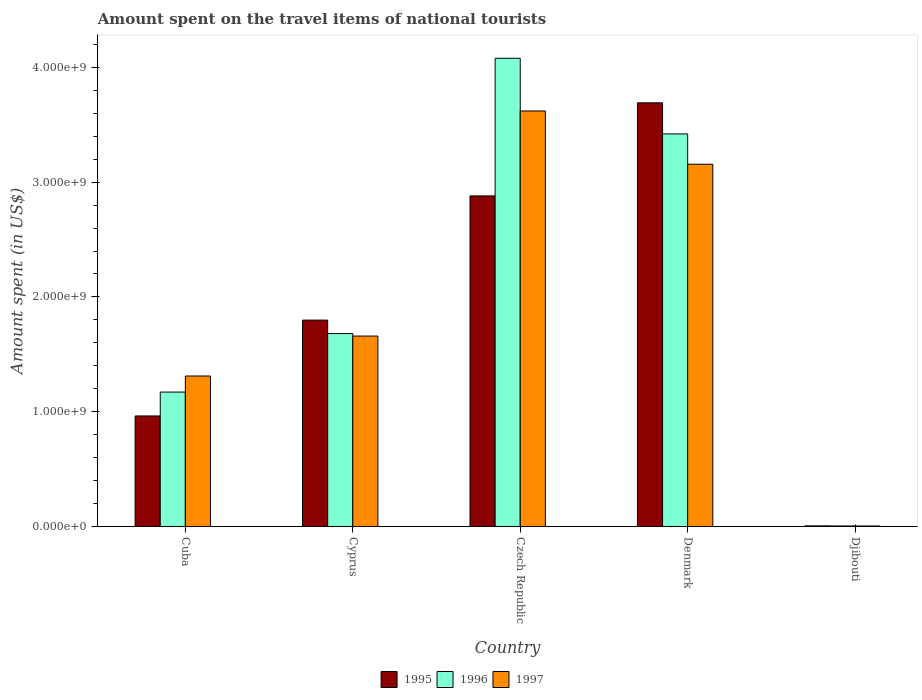How many groups of bars are there?
Offer a very short reply. 5. Are the number of bars per tick equal to the number of legend labels?
Your answer should be very brief. Yes. Are the number of bars on each tick of the X-axis equal?
Your answer should be very brief. Yes. How many bars are there on the 3rd tick from the right?
Your answer should be very brief. 3. What is the label of the 2nd group of bars from the left?
Provide a short and direct response. Cyprus. What is the amount spent on the travel items of national tourists in 1995 in Cuba?
Ensure brevity in your answer.  9.63e+08. Across all countries, what is the maximum amount spent on the travel items of national tourists in 1996?
Keep it short and to the point. 4.08e+09. Across all countries, what is the minimum amount spent on the travel items of national tourists in 1997?
Offer a terse response. 4.20e+06. In which country was the amount spent on the travel items of national tourists in 1996 maximum?
Provide a short and direct response. Czech Republic. In which country was the amount spent on the travel items of national tourists in 1996 minimum?
Provide a short and direct response. Djibouti. What is the total amount spent on the travel items of national tourists in 1996 in the graph?
Ensure brevity in your answer.  1.04e+1. What is the difference between the amount spent on the travel items of national tourists in 1997 in Cuba and that in Czech Republic?
Keep it short and to the point. -2.31e+09. What is the difference between the amount spent on the travel items of national tourists in 1996 in Czech Republic and the amount spent on the travel items of national tourists in 1997 in Djibouti?
Give a very brief answer. 4.07e+09. What is the average amount spent on the travel items of national tourists in 1997 per country?
Give a very brief answer. 1.95e+09. What is the difference between the amount spent on the travel items of national tourists of/in 1996 and amount spent on the travel items of national tourists of/in 1997 in Djibouti?
Keep it short and to the point. 4.00e+05. What is the ratio of the amount spent on the travel items of national tourists in 1996 in Cuba to that in Djibouti?
Ensure brevity in your answer.  254.57. What is the difference between the highest and the second highest amount spent on the travel items of national tourists in 1996?
Your answer should be compact. 6.59e+08. What is the difference between the highest and the lowest amount spent on the travel items of national tourists in 1996?
Give a very brief answer. 4.07e+09. What does the 2nd bar from the right in Cyprus represents?
Provide a succinct answer. 1996. Is it the case that in every country, the sum of the amount spent on the travel items of national tourists in 1995 and amount spent on the travel items of national tourists in 1997 is greater than the amount spent on the travel items of national tourists in 1996?
Keep it short and to the point. Yes. How many countries are there in the graph?
Give a very brief answer. 5. What is the difference between two consecutive major ticks on the Y-axis?
Make the answer very short. 1.00e+09. Does the graph contain grids?
Provide a succinct answer. No. How many legend labels are there?
Provide a short and direct response. 3. What is the title of the graph?
Make the answer very short. Amount spent on the travel items of national tourists. What is the label or title of the Y-axis?
Your answer should be compact. Amount spent (in US$). What is the Amount spent (in US$) of 1995 in Cuba?
Offer a terse response. 9.63e+08. What is the Amount spent (in US$) in 1996 in Cuba?
Make the answer very short. 1.17e+09. What is the Amount spent (in US$) of 1997 in Cuba?
Provide a succinct answer. 1.31e+09. What is the Amount spent (in US$) of 1995 in Cyprus?
Make the answer very short. 1.80e+09. What is the Amount spent (in US$) in 1996 in Cyprus?
Keep it short and to the point. 1.68e+09. What is the Amount spent (in US$) in 1997 in Cyprus?
Your response must be concise. 1.66e+09. What is the Amount spent (in US$) of 1995 in Czech Republic?
Your answer should be compact. 2.88e+09. What is the Amount spent (in US$) of 1996 in Czech Republic?
Your answer should be compact. 4.08e+09. What is the Amount spent (in US$) in 1997 in Czech Republic?
Offer a very short reply. 3.62e+09. What is the Amount spent (in US$) in 1995 in Denmark?
Offer a terse response. 3.69e+09. What is the Amount spent (in US$) of 1996 in Denmark?
Your response must be concise. 3.42e+09. What is the Amount spent (in US$) of 1997 in Denmark?
Provide a succinct answer. 3.16e+09. What is the Amount spent (in US$) of 1995 in Djibouti?
Provide a short and direct response. 5.40e+06. What is the Amount spent (in US$) of 1996 in Djibouti?
Ensure brevity in your answer.  4.60e+06. What is the Amount spent (in US$) in 1997 in Djibouti?
Give a very brief answer. 4.20e+06. Across all countries, what is the maximum Amount spent (in US$) of 1995?
Your answer should be compact. 3.69e+09. Across all countries, what is the maximum Amount spent (in US$) in 1996?
Your answer should be compact. 4.08e+09. Across all countries, what is the maximum Amount spent (in US$) in 1997?
Ensure brevity in your answer.  3.62e+09. Across all countries, what is the minimum Amount spent (in US$) of 1995?
Offer a terse response. 5.40e+06. Across all countries, what is the minimum Amount spent (in US$) of 1996?
Offer a very short reply. 4.60e+06. Across all countries, what is the minimum Amount spent (in US$) in 1997?
Your response must be concise. 4.20e+06. What is the total Amount spent (in US$) in 1995 in the graph?
Offer a terse response. 9.34e+09. What is the total Amount spent (in US$) in 1996 in the graph?
Provide a succinct answer. 1.04e+1. What is the total Amount spent (in US$) in 1997 in the graph?
Provide a short and direct response. 9.75e+09. What is the difference between the Amount spent (in US$) of 1995 in Cuba and that in Cyprus?
Your response must be concise. -8.35e+08. What is the difference between the Amount spent (in US$) of 1996 in Cuba and that in Cyprus?
Keep it short and to the point. -5.10e+08. What is the difference between the Amount spent (in US$) of 1997 in Cuba and that in Cyprus?
Offer a terse response. -3.48e+08. What is the difference between the Amount spent (in US$) of 1995 in Cuba and that in Czech Republic?
Your answer should be compact. -1.92e+09. What is the difference between the Amount spent (in US$) in 1996 in Cuba and that in Czech Republic?
Make the answer very short. -2.91e+09. What is the difference between the Amount spent (in US$) in 1997 in Cuba and that in Czech Republic?
Give a very brief answer. -2.31e+09. What is the difference between the Amount spent (in US$) in 1995 in Cuba and that in Denmark?
Make the answer very short. -2.73e+09. What is the difference between the Amount spent (in US$) in 1996 in Cuba and that in Denmark?
Keep it short and to the point. -2.25e+09. What is the difference between the Amount spent (in US$) in 1997 in Cuba and that in Denmark?
Give a very brief answer. -1.84e+09. What is the difference between the Amount spent (in US$) of 1995 in Cuba and that in Djibouti?
Your answer should be compact. 9.58e+08. What is the difference between the Amount spent (in US$) of 1996 in Cuba and that in Djibouti?
Offer a terse response. 1.17e+09. What is the difference between the Amount spent (in US$) in 1997 in Cuba and that in Djibouti?
Provide a short and direct response. 1.31e+09. What is the difference between the Amount spent (in US$) of 1995 in Cyprus and that in Czech Republic?
Your answer should be very brief. -1.08e+09. What is the difference between the Amount spent (in US$) in 1996 in Cyprus and that in Czech Republic?
Keep it short and to the point. -2.40e+09. What is the difference between the Amount spent (in US$) in 1997 in Cyprus and that in Czech Republic?
Give a very brief answer. -1.96e+09. What is the difference between the Amount spent (in US$) of 1995 in Cyprus and that in Denmark?
Keep it short and to the point. -1.89e+09. What is the difference between the Amount spent (in US$) of 1996 in Cyprus and that in Denmark?
Your answer should be very brief. -1.74e+09. What is the difference between the Amount spent (in US$) of 1997 in Cyprus and that in Denmark?
Offer a terse response. -1.50e+09. What is the difference between the Amount spent (in US$) in 1995 in Cyprus and that in Djibouti?
Offer a very short reply. 1.79e+09. What is the difference between the Amount spent (in US$) in 1996 in Cyprus and that in Djibouti?
Your response must be concise. 1.68e+09. What is the difference between the Amount spent (in US$) in 1997 in Cyprus and that in Djibouti?
Your answer should be very brief. 1.65e+09. What is the difference between the Amount spent (in US$) of 1995 in Czech Republic and that in Denmark?
Keep it short and to the point. -8.11e+08. What is the difference between the Amount spent (in US$) of 1996 in Czech Republic and that in Denmark?
Offer a terse response. 6.59e+08. What is the difference between the Amount spent (in US$) of 1997 in Czech Republic and that in Denmark?
Your answer should be very brief. 4.64e+08. What is the difference between the Amount spent (in US$) of 1995 in Czech Republic and that in Djibouti?
Your response must be concise. 2.87e+09. What is the difference between the Amount spent (in US$) in 1996 in Czech Republic and that in Djibouti?
Offer a very short reply. 4.07e+09. What is the difference between the Amount spent (in US$) of 1997 in Czech Republic and that in Djibouti?
Make the answer very short. 3.62e+09. What is the difference between the Amount spent (in US$) of 1995 in Denmark and that in Djibouti?
Provide a short and direct response. 3.69e+09. What is the difference between the Amount spent (in US$) in 1996 in Denmark and that in Djibouti?
Provide a short and direct response. 3.42e+09. What is the difference between the Amount spent (in US$) of 1997 in Denmark and that in Djibouti?
Your response must be concise. 3.15e+09. What is the difference between the Amount spent (in US$) of 1995 in Cuba and the Amount spent (in US$) of 1996 in Cyprus?
Your response must be concise. -7.18e+08. What is the difference between the Amount spent (in US$) of 1995 in Cuba and the Amount spent (in US$) of 1997 in Cyprus?
Your answer should be very brief. -6.96e+08. What is the difference between the Amount spent (in US$) of 1996 in Cuba and the Amount spent (in US$) of 1997 in Cyprus?
Offer a terse response. -4.88e+08. What is the difference between the Amount spent (in US$) of 1995 in Cuba and the Amount spent (in US$) of 1996 in Czech Republic?
Make the answer very short. -3.12e+09. What is the difference between the Amount spent (in US$) of 1995 in Cuba and the Amount spent (in US$) of 1997 in Czech Republic?
Offer a terse response. -2.66e+09. What is the difference between the Amount spent (in US$) of 1996 in Cuba and the Amount spent (in US$) of 1997 in Czech Republic?
Your response must be concise. -2.45e+09. What is the difference between the Amount spent (in US$) in 1995 in Cuba and the Amount spent (in US$) in 1996 in Denmark?
Provide a short and direct response. -2.46e+09. What is the difference between the Amount spent (in US$) in 1995 in Cuba and the Amount spent (in US$) in 1997 in Denmark?
Ensure brevity in your answer.  -2.19e+09. What is the difference between the Amount spent (in US$) of 1996 in Cuba and the Amount spent (in US$) of 1997 in Denmark?
Give a very brief answer. -1.98e+09. What is the difference between the Amount spent (in US$) in 1995 in Cuba and the Amount spent (in US$) in 1996 in Djibouti?
Your answer should be very brief. 9.58e+08. What is the difference between the Amount spent (in US$) of 1995 in Cuba and the Amount spent (in US$) of 1997 in Djibouti?
Ensure brevity in your answer.  9.59e+08. What is the difference between the Amount spent (in US$) of 1996 in Cuba and the Amount spent (in US$) of 1997 in Djibouti?
Your answer should be very brief. 1.17e+09. What is the difference between the Amount spent (in US$) in 1995 in Cyprus and the Amount spent (in US$) in 1996 in Czech Republic?
Make the answer very short. -2.28e+09. What is the difference between the Amount spent (in US$) of 1995 in Cyprus and the Amount spent (in US$) of 1997 in Czech Republic?
Your response must be concise. -1.82e+09. What is the difference between the Amount spent (in US$) in 1996 in Cyprus and the Amount spent (in US$) in 1997 in Czech Republic?
Provide a succinct answer. -1.94e+09. What is the difference between the Amount spent (in US$) in 1995 in Cyprus and the Amount spent (in US$) in 1996 in Denmark?
Keep it short and to the point. -1.62e+09. What is the difference between the Amount spent (in US$) in 1995 in Cyprus and the Amount spent (in US$) in 1997 in Denmark?
Give a very brief answer. -1.36e+09. What is the difference between the Amount spent (in US$) in 1996 in Cyprus and the Amount spent (in US$) in 1997 in Denmark?
Ensure brevity in your answer.  -1.48e+09. What is the difference between the Amount spent (in US$) in 1995 in Cyprus and the Amount spent (in US$) in 1996 in Djibouti?
Your response must be concise. 1.79e+09. What is the difference between the Amount spent (in US$) in 1995 in Cyprus and the Amount spent (in US$) in 1997 in Djibouti?
Your answer should be very brief. 1.79e+09. What is the difference between the Amount spent (in US$) of 1996 in Cyprus and the Amount spent (in US$) of 1997 in Djibouti?
Your answer should be compact. 1.68e+09. What is the difference between the Amount spent (in US$) in 1995 in Czech Republic and the Amount spent (in US$) in 1996 in Denmark?
Your answer should be compact. -5.40e+08. What is the difference between the Amount spent (in US$) of 1995 in Czech Republic and the Amount spent (in US$) of 1997 in Denmark?
Your response must be concise. -2.76e+08. What is the difference between the Amount spent (in US$) of 1996 in Czech Republic and the Amount spent (in US$) of 1997 in Denmark?
Offer a terse response. 9.23e+08. What is the difference between the Amount spent (in US$) in 1995 in Czech Republic and the Amount spent (in US$) in 1996 in Djibouti?
Your answer should be very brief. 2.88e+09. What is the difference between the Amount spent (in US$) in 1995 in Czech Republic and the Amount spent (in US$) in 1997 in Djibouti?
Give a very brief answer. 2.88e+09. What is the difference between the Amount spent (in US$) in 1996 in Czech Republic and the Amount spent (in US$) in 1997 in Djibouti?
Provide a succinct answer. 4.07e+09. What is the difference between the Amount spent (in US$) of 1995 in Denmark and the Amount spent (in US$) of 1996 in Djibouti?
Offer a terse response. 3.69e+09. What is the difference between the Amount spent (in US$) in 1995 in Denmark and the Amount spent (in US$) in 1997 in Djibouti?
Keep it short and to the point. 3.69e+09. What is the difference between the Amount spent (in US$) in 1996 in Denmark and the Amount spent (in US$) in 1997 in Djibouti?
Offer a very short reply. 3.42e+09. What is the average Amount spent (in US$) of 1995 per country?
Provide a succinct answer. 1.87e+09. What is the average Amount spent (in US$) in 1996 per country?
Your answer should be very brief. 2.07e+09. What is the average Amount spent (in US$) in 1997 per country?
Ensure brevity in your answer.  1.95e+09. What is the difference between the Amount spent (in US$) in 1995 and Amount spent (in US$) in 1996 in Cuba?
Provide a succinct answer. -2.08e+08. What is the difference between the Amount spent (in US$) in 1995 and Amount spent (in US$) in 1997 in Cuba?
Ensure brevity in your answer.  -3.48e+08. What is the difference between the Amount spent (in US$) in 1996 and Amount spent (in US$) in 1997 in Cuba?
Offer a terse response. -1.40e+08. What is the difference between the Amount spent (in US$) of 1995 and Amount spent (in US$) of 1996 in Cyprus?
Your answer should be very brief. 1.17e+08. What is the difference between the Amount spent (in US$) of 1995 and Amount spent (in US$) of 1997 in Cyprus?
Your answer should be compact. 1.39e+08. What is the difference between the Amount spent (in US$) of 1996 and Amount spent (in US$) of 1997 in Cyprus?
Your answer should be compact. 2.20e+07. What is the difference between the Amount spent (in US$) in 1995 and Amount spent (in US$) in 1996 in Czech Republic?
Your response must be concise. -1.20e+09. What is the difference between the Amount spent (in US$) of 1995 and Amount spent (in US$) of 1997 in Czech Republic?
Provide a succinct answer. -7.40e+08. What is the difference between the Amount spent (in US$) of 1996 and Amount spent (in US$) of 1997 in Czech Republic?
Provide a succinct answer. 4.59e+08. What is the difference between the Amount spent (in US$) of 1995 and Amount spent (in US$) of 1996 in Denmark?
Your response must be concise. 2.71e+08. What is the difference between the Amount spent (in US$) in 1995 and Amount spent (in US$) in 1997 in Denmark?
Your response must be concise. 5.35e+08. What is the difference between the Amount spent (in US$) of 1996 and Amount spent (in US$) of 1997 in Denmark?
Your answer should be compact. 2.64e+08. What is the difference between the Amount spent (in US$) in 1995 and Amount spent (in US$) in 1997 in Djibouti?
Give a very brief answer. 1.20e+06. What is the difference between the Amount spent (in US$) in 1996 and Amount spent (in US$) in 1997 in Djibouti?
Provide a short and direct response. 4.00e+05. What is the ratio of the Amount spent (in US$) in 1995 in Cuba to that in Cyprus?
Provide a succinct answer. 0.54. What is the ratio of the Amount spent (in US$) of 1996 in Cuba to that in Cyprus?
Offer a very short reply. 0.7. What is the ratio of the Amount spent (in US$) in 1997 in Cuba to that in Cyprus?
Provide a short and direct response. 0.79. What is the ratio of the Amount spent (in US$) in 1995 in Cuba to that in Czech Republic?
Keep it short and to the point. 0.33. What is the ratio of the Amount spent (in US$) in 1996 in Cuba to that in Czech Republic?
Give a very brief answer. 0.29. What is the ratio of the Amount spent (in US$) in 1997 in Cuba to that in Czech Republic?
Your answer should be very brief. 0.36. What is the ratio of the Amount spent (in US$) of 1995 in Cuba to that in Denmark?
Offer a very short reply. 0.26. What is the ratio of the Amount spent (in US$) in 1996 in Cuba to that in Denmark?
Your response must be concise. 0.34. What is the ratio of the Amount spent (in US$) in 1997 in Cuba to that in Denmark?
Ensure brevity in your answer.  0.42. What is the ratio of the Amount spent (in US$) in 1995 in Cuba to that in Djibouti?
Make the answer very short. 178.33. What is the ratio of the Amount spent (in US$) in 1996 in Cuba to that in Djibouti?
Ensure brevity in your answer.  254.57. What is the ratio of the Amount spent (in US$) in 1997 in Cuba to that in Djibouti?
Your answer should be very brief. 312.14. What is the ratio of the Amount spent (in US$) of 1995 in Cyprus to that in Czech Republic?
Offer a very short reply. 0.62. What is the ratio of the Amount spent (in US$) in 1996 in Cyprus to that in Czech Republic?
Give a very brief answer. 0.41. What is the ratio of the Amount spent (in US$) of 1997 in Cyprus to that in Czech Republic?
Your answer should be very brief. 0.46. What is the ratio of the Amount spent (in US$) of 1995 in Cyprus to that in Denmark?
Your response must be concise. 0.49. What is the ratio of the Amount spent (in US$) of 1996 in Cyprus to that in Denmark?
Make the answer very short. 0.49. What is the ratio of the Amount spent (in US$) of 1997 in Cyprus to that in Denmark?
Give a very brief answer. 0.53. What is the ratio of the Amount spent (in US$) in 1995 in Cyprus to that in Djibouti?
Ensure brevity in your answer.  332.96. What is the ratio of the Amount spent (in US$) in 1996 in Cyprus to that in Djibouti?
Provide a succinct answer. 365.43. What is the ratio of the Amount spent (in US$) in 1997 in Cyprus to that in Djibouti?
Ensure brevity in your answer.  395. What is the ratio of the Amount spent (in US$) in 1995 in Czech Republic to that in Denmark?
Your response must be concise. 0.78. What is the ratio of the Amount spent (in US$) in 1996 in Czech Republic to that in Denmark?
Provide a short and direct response. 1.19. What is the ratio of the Amount spent (in US$) in 1997 in Czech Republic to that in Denmark?
Your answer should be very brief. 1.15. What is the ratio of the Amount spent (in US$) in 1995 in Czech Republic to that in Djibouti?
Your response must be concise. 533.33. What is the ratio of the Amount spent (in US$) of 1996 in Czech Republic to that in Djibouti?
Your answer should be very brief. 886.74. What is the ratio of the Amount spent (in US$) of 1997 in Czech Republic to that in Djibouti?
Offer a very short reply. 861.9. What is the ratio of the Amount spent (in US$) of 1995 in Denmark to that in Djibouti?
Your response must be concise. 683.52. What is the ratio of the Amount spent (in US$) of 1996 in Denmark to that in Djibouti?
Provide a succinct answer. 743.48. What is the ratio of the Amount spent (in US$) of 1997 in Denmark to that in Djibouti?
Keep it short and to the point. 751.43. What is the difference between the highest and the second highest Amount spent (in US$) in 1995?
Ensure brevity in your answer.  8.11e+08. What is the difference between the highest and the second highest Amount spent (in US$) of 1996?
Provide a succinct answer. 6.59e+08. What is the difference between the highest and the second highest Amount spent (in US$) of 1997?
Offer a terse response. 4.64e+08. What is the difference between the highest and the lowest Amount spent (in US$) in 1995?
Offer a very short reply. 3.69e+09. What is the difference between the highest and the lowest Amount spent (in US$) of 1996?
Offer a very short reply. 4.07e+09. What is the difference between the highest and the lowest Amount spent (in US$) of 1997?
Offer a terse response. 3.62e+09. 